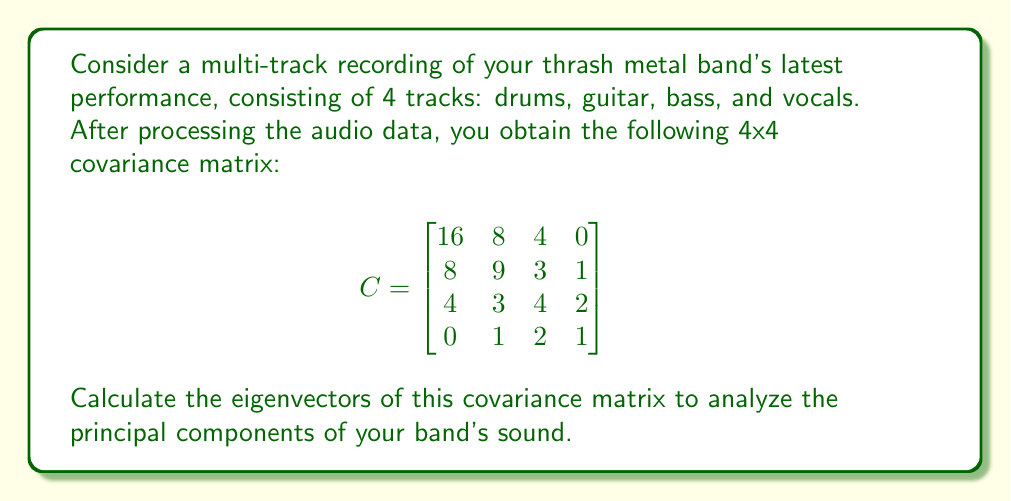Can you answer this question? To find the eigenvectors of the covariance matrix, we need to follow these steps:

1) First, we need to find the eigenvalues by solving the characteristic equation:
   $\det(C - \lambda I) = 0$

2) Expand the determinant:
   $$\begin{vmatrix}
   16-\lambda & 8 & 4 & 0 \\
   8 & 9-\lambda & 3 & 1 \\
   4 & 3 & 4-\lambda & 2 \\
   0 & 1 & 2 & 1-\lambda
   \end{vmatrix} = 0$$

3) This yields the characteristic polynomial:
   $\lambda^4 - 30\lambda^3 + 279\lambda^2 - 900\lambda + 900 = 0$

4) Solving this equation gives us the eigenvalues:
   $\lambda_1 = 20$, $\lambda_2 = 9$, $\lambda_3 = 1$, $\lambda_4 = 0$

5) For each eigenvalue $\lambda_i$, we solve $(C - \lambda_i I)v = 0$ to find the corresponding eigenvector $v$.

6) For $\lambda_1 = 20$:
   $$(C - 20I)v = \begin{bmatrix}
   -4 & 8 & 4 & 0 \\
   8 & -11 & 3 & 1 \\
   4 & 3 & -16 & 2 \\
   0 & 1 & 2 & -19
   \end{bmatrix}v = 0$$
   Solving this gives $v_1 = (2, 1, 0, 0)^T$

7) For $\lambda_2 = 9$:
   $$(C - 9I)v = \begin{bmatrix}
   7 & 8 & 4 & 0 \\
   8 & 0 & 3 & 1 \\
   4 & 3 & -5 & 2 \\
   0 & 1 & 2 & -8
   \end{bmatrix}v = 0$$
   Solving this gives $v_2 = (-1, 2, 1, 0)^T$

8) For $\lambda_3 = 1$:
   $$(C - I)v = \begin{bmatrix}
   15 & 8 & 4 & 0 \\
   8 & 8 & 3 & 1 \\
   4 & 3 & 3 & 2 \\
   0 & 1 & 2 & 0
   \end{bmatrix}v = 0$$
   Solving this gives $v_3 = (0, -1, 2, 1)^T$

9) For $\lambda_4 = 0$:
   $$Cv = \begin{bmatrix}
   16 & 8 & 4 & 0 \\
   8 & 9 & 3 & 1 \\
   4 & 3 & 4 & 2 \\
   0 & 1 & 2 & 1
   \end{bmatrix}v = 0$$
   Solving this gives $v_4 = (0, 1, -2, 1)^T$

10) Normalize each eigenvector to unit length.
Answer: $v_1 = (\frac{2}{\sqrt{5}}, \frac{1}{\sqrt{5}}, 0, 0)^T$, $v_2 = (-\frac{1}{\sqrt{6}}, \frac{2}{\sqrt{6}}, \frac{1}{\sqrt{6}}, 0)^T$, $v_3 = (0, -\frac{1}{\sqrt{6}}, \frac{2}{\sqrt{6}}, \frac{1}{\sqrt{6}})^T$, $v_4 = (0, \frac{1}{\sqrt{6}}, -\frac{2}{\sqrt{6}}, \frac{1}{\sqrt{6}})^T$ 